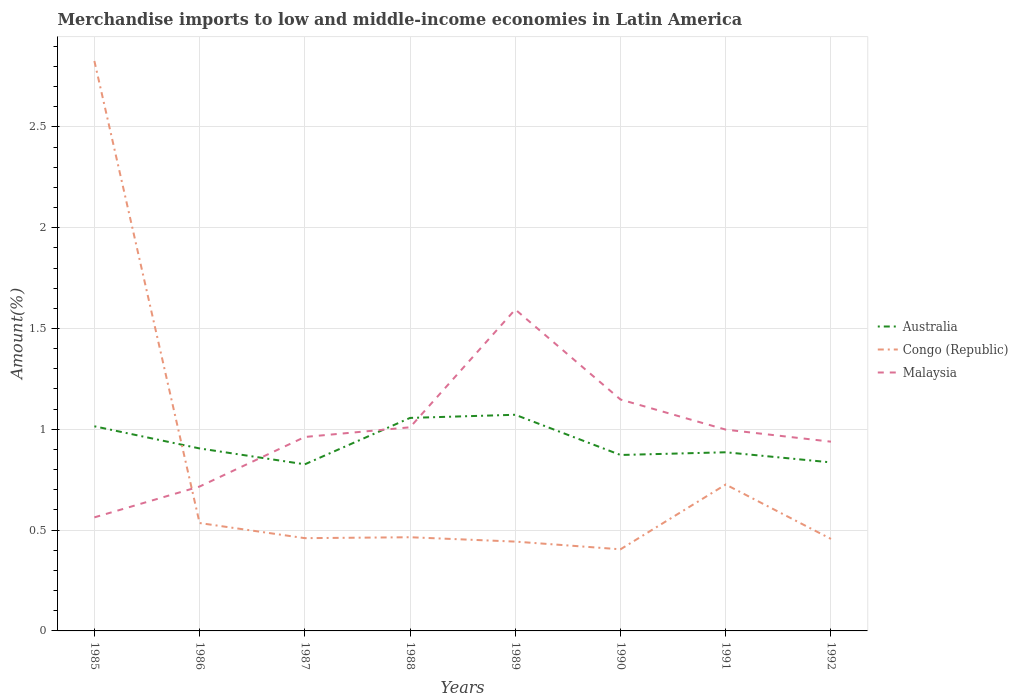Does the line corresponding to Australia intersect with the line corresponding to Congo (Republic)?
Provide a succinct answer. Yes. Across all years, what is the maximum percentage of amount earned from merchandise imports in Malaysia?
Provide a short and direct response. 0.56. In which year was the percentage of amount earned from merchandise imports in Congo (Republic) maximum?
Your answer should be compact. 1990. What is the total percentage of amount earned from merchandise imports in Malaysia in the graph?
Your answer should be very brief. -0.88. What is the difference between the highest and the second highest percentage of amount earned from merchandise imports in Australia?
Provide a succinct answer. 0.25. How many lines are there?
Give a very brief answer. 3. How many years are there in the graph?
Offer a terse response. 8. Are the values on the major ticks of Y-axis written in scientific E-notation?
Your response must be concise. No. What is the title of the graph?
Your answer should be compact. Merchandise imports to low and middle-income economies in Latin America. Does "Turkey" appear as one of the legend labels in the graph?
Make the answer very short. No. What is the label or title of the Y-axis?
Ensure brevity in your answer.  Amount(%). What is the Amount(%) of Australia in 1985?
Ensure brevity in your answer.  1.01. What is the Amount(%) in Congo (Republic) in 1985?
Your response must be concise. 2.83. What is the Amount(%) of Malaysia in 1985?
Provide a short and direct response. 0.56. What is the Amount(%) of Australia in 1986?
Provide a succinct answer. 0.91. What is the Amount(%) of Congo (Republic) in 1986?
Keep it short and to the point. 0.54. What is the Amount(%) of Malaysia in 1986?
Make the answer very short. 0.72. What is the Amount(%) of Australia in 1987?
Your answer should be very brief. 0.83. What is the Amount(%) of Congo (Republic) in 1987?
Ensure brevity in your answer.  0.46. What is the Amount(%) in Malaysia in 1987?
Your answer should be compact. 0.96. What is the Amount(%) of Australia in 1988?
Offer a very short reply. 1.06. What is the Amount(%) of Congo (Republic) in 1988?
Make the answer very short. 0.46. What is the Amount(%) of Malaysia in 1988?
Provide a short and direct response. 1.01. What is the Amount(%) in Australia in 1989?
Your answer should be compact. 1.07. What is the Amount(%) in Congo (Republic) in 1989?
Provide a succinct answer. 0.44. What is the Amount(%) in Malaysia in 1989?
Offer a very short reply. 1.59. What is the Amount(%) in Australia in 1990?
Offer a terse response. 0.87. What is the Amount(%) of Congo (Republic) in 1990?
Make the answer very short. 0.4. What is the Amount(%) of Malaysia in 1990?
Offer a terse response. 1.15. What is the Amount(%) of Australia in 1991?
Your response must be concise. 0.89. What is the Amount(%) of Congo (Republic) in 1991?
Your answer should be compact. 0.73. What is the Amount(%) of Malaysia in 1991?
Provide a succinct answer. 1. What is the Amount(%) of Australia in 1992?
Provide a succinct answer. 0.84. What is the Amount(%) of Congo (Republic) in 1992?
Your answer should be very brief. 0.46. What is the Amount(%) of Malaysia in 1992?
Your answer should be compact. 0.94. Across all years, what is the maximum Amount(%) of Australia?
Offer a very short reply. 1.07. Across all years, what is the maximum Amount(%) of Congo (Republic)?
Your response must be concise. 2.83. Across all years, what is the maximum Amount(%) in Malaysia?
Your response must be concise. 1.59. Across all years, what is the minimum Amount(%) in Australia?
Provide a short and direct response. 0.83. Across all years, what is the minimum Amount(%) of Congo (Republic)?
Ensure brevity in your answer.  0.4. Across all years, what is the minimum Amount(%) of Malaysia?
Offer a very short reply. 0.56. What is the total Amount(%) in Australia in the graph?
Provide a succinct answer. 7.47. What is the total Amount(%) of Congo (Republic) in the graph?
Keep it short and to the point. 6.32. What is the total Amount(%) of Malaysia in the graph?
Offer a terse response. 7.93. What is the difference between the Amount(%) of Australia in 1985 and that in 1986?
Give a very brief answer. 0.11. What is the difference between the Amount(%) of Congo (Republic) in 1985 and that in 1986?
Your answer should be compact. 2.29. What is the difference between the Amount(%) in Malaysia in 1985 and that in 1986?
Make the answer very short. -0.15. What is the difference between the Amount(%) of Australia in 1985 and that in 1987?
Give a very brief answer. 0.19. What is the difference between the Amount(%) of Congo (Republic) in 1985 and that in 1987?
Offer a terse response. 2.37. What is the difference between the Amount(%) in Malaysia in 1985 and that in 1987?
Keep it short and to the point. -0.4. What is the difference between the Amount(%) in Australia in 1985 and that in 1988?
Ensure brevity in your answer.  -0.04. What is the difference between the Amount(%) of Congo (Republic) in 1985 and that in 1988?
Offer a very short reply. 2.36. What is the difference between the Amount(%) in Malaysia in 1985 and that in 1988?
Provide a succinct answer. -0.45. What is the difference between the Amount(%) in Australia in 1985 and that in 1989?
Make the answer very short. -0.06. What is the difference between the Amount(%) in Congo (Republic) in 1985 and that in 1989?
Provide a succinct answer. 2.38. What is the difference between the Amount(%) in Malaysia in 1985 and that in 1989?
Give a very brief answer. -1.03. What is the difference between the Amount(%) in Australia in 1985 and that in 1990?
Keep it short and to the point. 0.14. What is the difference between the Amount(%) in Congo (Republic) in 1985 and that in 1990?
Your answer should be very brief. 2.42. What is the difference between the Amount(%) of Malaysia in 1985 and that in 1990?
Your answer should be very brief. -0.58. What is the difference between the Amount(%) of Australia in 1985 and that in 1991?
Provide a succinct answer. 0.13. What is the difference between the Amount(%) in Congo (Republic) in 1985 and that in 1991?
Keep it short and to the point. 2.1. What is the difference between the Amount(%) of Malaysia in 1985 and that in 1991?
Keep it short and to the point. -0.44. What is the difference between the Amount(%) of Australia in 1985 and that in 1992?
Your response must be concise. 0.18. What is the difference between the Amount(%) of Congo (Republic) in 1985 and that in 1992?
Your response must be concise. 2.37. What is the difference between the Amount(%) of Malaysia in 1985 and that in 1992?
Provide a succinct answer. -0.38. What is the difference between the Amount(%) of Australia in 1986 and that in 1987?
Offer a very short reply. 0.08. What is the difference between the Amount(%) of Congo (Republic) in 1986 and that in 1987?
Ensure brevity in your answer.  0.07. What is the difference between the Amount(%) of Malaysia in 1986 and that in 1987?
Provide a succinct answer. -0.25. What is the difference between the Amount(%) of Australia in 1986 and that in 1988?
Your answer should be very brief. -0.15. What is the difference between the Amount(%) of Congo (Republic) in 1986 and that in 1988?
Your answer should be very brief. 0.07. What is the difference between the Amount(%) in Malaysia in 1986 and that in 1988?
Offer a very short reply. -0.29. What is the difference between the Amount(%) in Australia in 1986 and that in 1989?
Make the answer very short. -0.17. What is the difference between the Amount(%) of Congo (Republic) in 1986 and that in 1989?
Make the answer very short. 0.09. What is the difference between the Amount(%) in Malaysia in 1986 and that in 1989?
Keep it short and to the point. -0.88. What is the difference between the Amount(%) of Australia in 1986 and that in 1990?
Your answer should be very brief. 0.03. What is the difference between the Amount(%) of Congo (Republic) in 1986 and that in 1990?
Your answer should be compact. 0.13. What is the difference between the Amount(%) in Malaysia in 1986 and that in 1990?
Your answer should be compact. -0.43. What is the difference between the Amount(%) of Australia in 1986 and that in 1991?
Offer a very short reply. 0.02. What is the difference between the Amount(%) in Congo (Republic) in 1986 and that in 1991?
Ensure brevity in your answer.  -0.19. What is the difference between the Amount(%) of Malaysia in 1986 and that in 1991?
Provide a short and direct response. -0.28. What is the difference between the Amount(%) in Australia in 1986 and that in 1992?
Your response must be concise. 0.07. What is the difference between the Amount(%) of Congo (Republic) in 1986 and that in 1992?
Give a very brief answer. 0.08. What is the difference between the Amount(%) of Malaysia in 1986 and that in 1992?
Your response must be concise. -0.22. What is the difference between the Amount(%) in Australia in 1987 and that in 1988?
Your answer should be compact. -0.23. What is the difference between the Amount(%) in Congo (Republic) in 1987 and that in 1988?
Give a very brief answer. -0. What is the difference between the Amount(%) in Malaysia in 1987 and that in 1988?
Give a very brief answer. -0.05. What is the difference between the Amount(%) of Australia in 1987 and that in 1989?
Offer a very short reply. -0.25. What is the difference between the Amount(%) in Congo (Republic) in 1987 and that in 1989?
Provide a short and direct response. 0.02. What is the difference between the Amount(%) in Malaysia in 1987 and that in 1989?
Make the answer very short. -0.63. What is the difference between the Amount(%) of Australia in 1987 and that in 1990?
Provide a short and direct response. -0.05. What is the difference between the Amount(%) of Congo (Republic) in 1987 and that in 1990?
Keep it short and to the point. 0.06. What is the difference between the Amount(%) in Malaysia in 1987 and that in 1990?
Ensure brevity in your answer.  -0.19. What is the difference between the Amount(%) of Australia in 1987 and that in 1991?
Keep it short and to the point. -0.06. What is the difference between the Amount(%) of Congo (Republic) in 1987 and that in 1991?
Your response must be concise. -0.27. What is the difference between the Amount(%) in Malaysia in 1987 and that in 1991?
Provide a succinct answer. -0.04. What is the difference between the Amount(%) of Australia in 1987 and that in 1992?
Your answer should be compact. -0.01. What is the difference between the Amount(%) in Congo (Republic) in 1987 and that in 1992?
Give a very brief answer. 0. What is the difference between the Amount(%) in Malaysia in 1987 and that in 1992?
Give a very brief answer. 0.02. What is the difference between the Amount(%) in Australia in 1988 and that in 1989?
Your answer should be very brief. -0.02. What is the difference between the Amount(%) in Congo (Republic) in 1988 and that in 1989?
Offer a terse response. 0.02. What is the difference between the Amount(%) in Malaysia in 1988 and that in 1989?
Ensure brevity in your answer.  -0.58. What is the difference between the Amount(%) in Australia in 1988 and that in 1990?
Your answer should be compact. 0.18. What is the difference between the Amount(%) in Congo (Republic) in 1988 and that in 1990?
Your response must be concise. 0.06. What is the difference between the Amount(%) in Malaysia in 1988 and that in 1990?
Give a very brief answer. -0.14. What is the difference between the Amount(%) in Australia in 1988 and that in 1991?
Provide a succinct answer. 0.17. What is the difference between the Amount(%) of Congo (Republic) in 1988 and that in 1991?
Ensure brevity in your answer.  -0.26. What is the difference between the Amount(%) in Malaysia in 1988 and that in 1991?
Your answer should be very brief. 0.01. What is the difference between the Amount(%) of Australia in 1988 and that in 1992?
Ensure brevity in your answer.  0.22. What is the difference between the Amount(%) of Congo (Republic) in 1988 and that in 1992?
Your answer should be very brief. 0.01. What is the difference between the Amount(%) of Malaysia in 1988 and that in 1992?
Provide a short and direct response. 0.07. What is the difference between the Amount(%) in Australia in 1989 and that in 1990?
Keep it short and to the point. 0.2. What is the difference between the Amount(%) in Congo (Republic) in 1989 and that in 1990?
Provide a succinct answer. 0.04. What is the difference between the Amount(%) in Malaysia in 1989 and that in 1990?
Provide a short and direct response. 0.45. What is the difference between the Amount(%) in Australia in 1989 and that in 1991?
Offer a very short reply. 0.19. What is the difference between the Amount(%) of Congo (Republic) in 1989 and that in 1991?
Provide a short and direct response. -0.28. What is the difference between the Amount(%) in Malaysia in 1989 and that in 1991?
Keep it short and to the point. 0.6. What is the difference between the Amount(%) of Australia in 1989 and that in 1992?
Provide a short and direct response. 0.24. What is the difference between the Amount(%) of Congo (Republic) in 1989 and that in 1992?
Ensure brevity in your answer.  -0.01. What is the difference between the Amount(%) in Malaysia in 1989 and that in 1992?
Your response must be concise. 0.66. What is the difference between the Amount(%) of Australia in 1990 and that in 1991?
Your answer should be compact. -0.01. What is the difference between the Amount(%) of Congo (Republic) in 1990 and that in 1991?
Keep it short and to the point. -0.32. What is the difference between the Amount(%) in Malaysia in 1990 and that in 1991?
Keep it short and to the point. 0.15. What is the difference between the Amount(%) in Australia in 1990 and that in 1992?
Make the answer very short. 0.04. What is the difference between the Amount(%) of Congo (Republic) in 1990 and that in 1992?
Your response must be concise. -0.05. What is the difference between the Amount(%) in Malaysia in 1990 and that in 1992?
Your response must be concise. 0.21. What is the difference between the Amount(%) of Australia in 1991 and that in 1992?
Your answer should be compact. 0.05. What is the difference between the Amount(%) of Congo (Republic) in 1991 and that in 1992?
Keep it short and to the point. 0.27. What is the difference between the Amount(%) of Malaysia in 1991 and that in 1992?
Your answer should be very brief. 0.06. What is the difference between the Amount(%) of Australia in 1985 and the Amount(%) of Congo (Republic) in 1986?
Your response must be concise. 0.48. What is the difference between the Amount(%) of Australia in 1985 and the Amount(%) of Malaysia in 1986?
Your response must be concise. 0.3. What is the difference between the Amount(%) in Congo (Republic) in 1985 and the Amount(%) in Malaysia in 1986?
Make the answer very short. 2.11. What is the difference between the Amount(%) in Australia in 1985 and the Amount(%) in Congo (Republic) in 1987?
Ensure brevity in your answer.  0.55. What is the difference between the Amount(%) in Australia in 1985 and the Amount(%) in Malaysia in 1987?
Your answer should be very brief. 0.05. What is the difference between the Amount(%) in Congo (Republic) in 1985 and the Amount(%) in Malaysia in 1987?
Provide a short and direct response. 1.86. What is the difference between the Amount(%) in Australia in 1985 and the Amount(%) in Congo (Republic) in 1988?
Your answer should be very brief. 0.55. What is the difference between the Amount(%) in Australia in 1985 and the Amount(%) in Malaysia in 1988?
Provide a short and direct response. 0.01. What is the difference between the Amount(%) of Congo (Republic) in 1985 and the Amount(%) of Malaysia in 1988?
Provide a short and direct response. 1.82. What is the difference between the Amount(%) in Australia in 1985 and the Amount(%) in Congo (Republic) in 1989?
Give a very brief answer. 0.57. What is the difference between the Amount(%) in Australia in 1985 and the Amount(%) in Malaysia in 1989?
Your answer should be very brief. -0.58. What is the difference between the Amount(%) in Congo (Republic) in 1985 and the Amount(%) in Malaysia in 1989?
Offer a terse response. 1.23. What is the difference between the Amount(%) of Australia in 1985 and the Amount(%) of Congo (Republic) in 1990?
Provide a short and direct response. 0.61. What is the difference between the Amount(%) of Australia in 1985 and the Amount(%) of Malaysia in 1990?
Give a very brief answer. -0.13. What is the difference between the Amount(%) of Congo (Republic) in 1985 and the Amount(%) of Malaysia in 1990?
Give a very brief answer. 1.68. What is the difference between the Amount(%) in Australia in 1985 and the Amount(%) in Congo (Republic) in 1991?
Offer a terse response. 0.29. What is the difference between the Amount(%) in Australia in 1985 and the Amount(%) in Malaysia in 1991?
Make the answer very short. 0.02. What is the difference between the Amount(%) in Congo (Republic) in 1985 and the Amount(%) in Malaysia in 1991?
Your response must be concise. 1.83. What is the difference between the Amount(%) of Australia in 1985 and the Amount(%) of Congo (Republic) in 1992?
Give a very brief answer. 0.56. What is the difference between the Amount(%) in Australia in 1985 and the Amount(%) in Malaysia in 1992?
Your response must be concise. 0.08. What is the difference between the Amount(%) of Congo (Republic) in 1985 and the Amount(%) of Malaysia in 1992?
Your answer should be very brief. 1.89. What is the difference between the Amount(%) of Australia in 1986 and the Amount(%) of Congo (Republic) in 1987?
Your answer should be compact. 0.45. What is the difference between the Amount(%) in Australia in 1986 and the Amount(%) in Malaysia in 1987?
Give a very brief answer. -0.06. What is the difference between the Amount(%) of Congo (Republic) in 1986 and the Amount(%) of Malaysia in 1987?
Give a very brief answer. -0.43. What is the difference between the Amount(%) in Australia in 1986 and the Amount(%) in Congo (Republic) in 1988?
Your response must be concise. 0.44. What is the difference between the Amount(%) in Australia in 1986 and the Amount(%) in Malaysia in 1988?
Offer a terse response. -0.1. What is the difference between the Amount(%) of Congo (Republic) in 1986 and the Amount(%) of Malaysia in 1988?
Ensure brevity in your answer.  -0.47. What is the difference between the Amount(%) of Australia in 1986 and the Amount(%) of Congo (Republic) in 1989?
Your answer should be very brief. 0.46. What is the difference between the Amount(%) in Australia in 1986 and the Amount(%) in Malaysia in 1989?
Offer a terse response. -0.69. What is the difference between the Amount(%) of Congo (Republic) in 1986 and the Amount(%) of Malaysia in 1989?
Provide a succinct answer. -1.06. What is the difference between the Amount(%) of Australia in 1986 and the Amount(%) of Congo (Republic) in 1990?
Your answer should be compact. 0.5. What is the difference between the Amount(%) of Australia in 1986 and the Amount(%) of Malaysia in 1990?
Offer a terse response. -0.24. What is the difference between the Amount(%) of Congo (Republic) in 1986 and the Amount(%) of Malaysia in 1990?
Ensure brevity in your answer.  -0.61. What is the difference between the Amount(%) in Australia in 1986 and the Amount(%) in Congo (Republic) in 1991?
Ensure brevity in your answer.  0.18. What is the difference between the Amount(%) of Australia in 1986 and the Amount(%) of Malaysia in 1991?
Offer a terse response. -0.09. What is the difference between the Amount(%) of Congo (Republic) in 1986 and the Amount(%) of Malaysia in 1991?
Give a very brief answer. -0.46. What is the difference between the Amount(%) in Australia in 1986 and the Amount(%) in Congo (Republic) in 1992?
Provide a succinct answer. 0.45. What is the difference between the Amount(%) in Australia in 1986 and the Amount(%) in Malaysia in 1992?
Make the answer very short. -0.03. What is the difference between the Amount(%) in Congo (Republic) in 1986 and the Amount(%) in Malaysia in 1992?
Provide a short and direct response. -0.4. What is the difference between the Amount(%) of Australia in 1987 and the Amount(%) of Congo (Republic) in 1988?
Your response must be concise. 0.36. What is the difference between the Amount(%) of Australia in 1987 and the Amount(%) of Malaysia in 1988?
Ensure brevity in your answer.  -0.18. What is the difference between the Amount(%) of Congo (Republic) in 1987 and the Amount(%) of Malaysia in 1988?
Offer a terse response. -0.55. What is the difference between the Amount(%) in Australia in 1987 and the Amount(%) in Congo (Republic) in 1989?
Keep it short and to the point. 0.38. What is the difference between the Amount(%) of Australia in 1987 and the Amount(%) of Malaysia in 1989?
Offer a very short reply. -0.77. What is the difference between the Amount(%) of Congo (Republic) in 1987 and the Amount(%) of Malaysia in 1989?
Make the answer very short. -1.13. What is the difference between the Amount(%) of Australia in 1987 and the Amount(%) of Congo (Republic) in 1990?
Provide a succinct answer. 0.42. What is the difference between the Amount(%) in Australia in 1987 and the Amount(%) in Malaysia in 1990?
Your answer should be compact. -0.32. What is the difference between the Amount(%) in Congo (Republic) in 1987 and the Amount(%) in Malaysia in 1990?
Provide a short and direct response. -0.69. What is the difference between the Amount(%) in Australia in 1987 and the Amount(%) in Congo (Republic) in 1991?
Make the answer very short. 0.1. What is the difference between the Amount(%) in Australia in 1987 and the Amount(%) in Malaysia in 1991?
Provide a succinct answer. -0.17. What is the difference between the Amount(%) of Congo (Republic) in 1987 and the Amount(%) of Malaysia in 1991?
Your answer should be very brief. -0.54. What is the difference between the Amount(%) in Australia in 1987 and the Amount(%) in Congo (Republic) in 1992?
Provide a succinct answer. 0.37. What is the difference between the Amount(%) of Australia in 1987 and the Amount(%) of Malaysia in 1992?
Offer a very short reply. -0.11. What is the difference between the Amount(%) in Congo (Republic) in 1987 and the Amount(%) in Malaysia in 1992?
Provide a succinct answer. -0.48. What is the difference between the Amount(%) in Australia in 1988 and the Amount(%) in Congo (Republic) in 1989?
Your answer should be very brief. 0.61. What is the difference between the Amount(%) in Australia in 1988 and the Amount(%) in Malaysia in 1989?
Provide a short and direct response. -0.54. What is the difference between the Amount(%) of Congo (Republic) in 1988 and the Amount(%) of Malaysia in 1989?
Offer a very short reply. -1.13. What is the difference between the Amount(%) of Australia in 1988 and the Amount(%) of Congo (Republic) in 1990?
Keep it short and to the point. 0.65. What is the difference between the Amount(%) of Australia in 1988 and the Amount(%) of Malaysia in 1990?
Make the answer very short. -0.09. What is the difference between the Amount(%) of Congo (Republic) in 1988 and the Amount(%) of Malaysia in 1990?
Keep it short and to the point. -0.68. What is the difference between the Amount(%) of Australia in 1988 and the Amount(%) of Congo (Republic) in 1991?
Provide a succinct answer. 0.33. What is the difference between the Amount(%) in Australia in 1988 and the Amount(%) in Malaysia in 1991?
Offer a very short reply. 0.06. What is the difference between the Amount(%) in Congo (Republic) in 1988 and the Amount(%) in Malaysia in 1991?
Offer a terse response. -0.53. What is the difference between the Amount(%) in Australia in 1988 and the Amount(%) in Congo (Republic) in 1992?
Keep it short and to the point. 0.6. What is the difference between the Amount(%) in Australia in 1988 and the Amount(%) in Malaysia in 1992?
Offer a terse response. 0.12. What is the difference between the Amount(%) in Congo (Republic) in 1988 and the Amount(%) in Malaysia in 1992?
Ensure brevity in your answer.  -0.47. What is the difference between the Amount(%) of Australia in 1989 and the Amount(%) of Congo (Republic) in 1990?
Offer a very short reply. 0.67. What is the difference between the Amount(%) of Australia in 1989 and the Amount(%) of Malaysia in 1990?
Offer a terse response. -0.08. What is the difference between the Amount(%) in Congo (Republic) in 1989 and the Amount(%) in Malaysia in 1990?
Provide a succinct answer. -0.7. What is the difference between the Amount(%) in Australia in 1989 and the Amount(%) in Congo (Republic) in 1991?
Make the answer very short. 0.35. What is the difference between the Amount(%) of Australia in 1989 and the Amount(%) of Malaysia in 1991?
Provide a short and direct response. 0.07. What is the difference between the Amount(%) of Congo (Republic) in 1989 and the Amount(%) of Malaysia in 1991?
Keep it short and to the point. -0.56. What is the difference between the Amount(%) of Australia in 1989 and the Amount(%) of Congo (Republic) in 1992?
Offer a terse response. 0.62. What is the difference between the Amount(%) of Australia in 1989 and the Amount(%) of Malaysia in 1992?
Give a very brief answer. 0.13. What is the difference between the Amount(%) in Congo (Republic) in 1989 and the Amount(%) in Malaysia in 1992?
Your answer should be very brief. -0.5. What is the difference between the Amount(%) of Australia in 1990 and the Amount(%) of Congo (Republic) in 1991?
Your response must be concise. 0.15. What is the difference between the Amount(%) in Australia in 1990 and the Amount(%) in Malaysia in 1991?
Keep it short and to the point. -0.13. What is the difference between the Amount(%) in Congo (Republic) in 1990 and the Amount(%) in Malaysia in 1991?
Give a very brief answer. -0.59. What is the difference between the Amount(%) in Australia in 1990 and the Amount(%) in Congo (Republic) in 1992?
Keep it short and to the point. 0.42. What is the difference between the Amount(%) in Australia in 1990 and the Amount(%) in Malaysia in 1992?
Ensure brevity in your answer.  -0.07. What is the difference between the Amount(%) of Congo (Republic) in 1990 and the Amount(%) of Malaysia in 1992?
Provide a short and direct response. -0.53. What is the difference between the Amount(%) in Australia in 1991 and the Amount(%) in Congo (Republic) in 1992?
Your answer should be very brief. 0.43. What is the difference between the Amount(%) of Australia in 1991 and the Amount(%) of Malaysia in 1992?
Ensure brevity in your answer.  -0.05. What is the difference between the Amount(%) in Congo (Republic) in 1991 and the Amount(%) in Malaysia in 1992?
Provide a short and direct response. -0.21. What is the average Amount(%) in Australia per year?
Your response must be concise. 0.93. What is the average Amount(%) in Congo (Republic) per year?
Make the answer very short. 0.79. What is the average Amount(%) in Malaysia per year?
Provide a short and direct response. 0.99. In the year 1985, what is the difference between the Amount(%) in Australia and Amount(%) in Congo (Republic)?
Offer a very short reply. -1.81. In the year 1985, what is the difference between the Amount(%) of Australia and Amount(%) of Malaysia?
Offer a very short reply. 0.45. In the year 1985, what is the difference between the Amount(%) in Congo (Republic) and Amount(%) in Malaysia?
Offer a terse response. 2.26. In the year 1986, what is the difference between the Amount(%) of Australia and Amount(%) of Congo (Republic)?
Your response must be concise. 0.37. In the year 1986, what is the difference between the Amount(%) in Australia and Amount(%) in Malaysia?
Provide a short and direct response. 0.19. In the year 1986, what is the difference between the Amount(%) in Congo (Republic) and Amount(%) in Malaysia?
Your response must be concise. -0.18. In the year 1987, what is the difference between the Amount(%) of Australia and Amount(%) of Congo (Republic)?
Offer a very short reply. 0.37. In the year 1987, what is the difference between the Amount(%) of Australia and Amount(%) of Malaysia?
Offer a very short reply. -0.14. In the year 1987, what is the difference between the Amount(%) of Congo (Republic) and Amount(%) of Malaysia?
Provide a short and direct response. -0.5. In the year 1988, what is the difference between the Amount(%) of Australia and Amount(%) of Congo (Republic)?
Give a very brief answer. 0.59. In the year 1988, what is the difference between the Amount(%) in Australia and Amount(%) in Malaysia?
Provide a short and direct response. 0.05. In the year 1988, what is the difference between the Amount(%) in Congo (Republic) and Amount(%) in Malaysia?
Your answer should be very brief. -0.55. In the year 1989, what is the difference between the Amount(%) in Australia and Amount(%) in Congo (Republic)?
Your answer should be very brief. 0.63. In the year 1989, what is the difference between the Amount(%) in Australia and Amount(%) in Malaysia?
Your answer should be very brief. -0.52. In the year 1989, what is the difference between the Amount(%) in Congo (Republic) and Amount(%) in Malaysia?
Your answer should be very brief. -1.15. In the year 1990, what is the difference between the Amount(%) in Australia and Amount(%) in Congo (Republic)?
Your answer should be compact. 0.47. In the year 1990, what is the difference between the Amount(%) in Australia and Amount(%) in Malaysia?
Keep it short and to the point. -0.28. In the year 1990, what is the difference between the Amount(%) of Congo (Republic) and Amount(%) of Malaysia?
Give a very brief answer. -0.74. In the year 1991, what is the difference between the Amount(%) of Australia and Amount(%) of Congo (Republic)?
Keep it short and to the point. 0.16. In the year 1991, what is the difference between the Amount(%) in Australia and Amount(%) in Malaysia?
Your answer should be very brief. -0.11. In the year 1991, what is the difference between the Amount(%) of Congo (Republic) and Amount(%) of Malaysia?
Your answer should be compact. -0.27. In the year 1992, what is the difference between the Amount(%) in Australia and Amount(%) in Congo (Republic)?
Your response must be concise. 0.38. In the year 1992, what is the difference between the Amount(%) in Australia and Amount(%) in Malaysia?
Offer a terse response. -0.1. In the year 1992, what is the difference between the Amount(%) in Congo (Republic) and Amount(%) in Malaysia?
Your answer should be very brief. -0.48. What is the ratio of the Amount(%) of Australia in 1985 to that in 1986?
Your response must be concise. 1.12. What is the ratio of the Amount(%) of Congo (Republic) in 1985 to that in 1986?
Your answer should be very brief. 5.28. What is the ratio of the Amount(%) in Malaysia in 1985 to that in 1986?
Offer a very short reply. 0.79. What is the ratio of the Amount(%) in Australia in 1985 to that in 1987?
Your answer should be very brief. 1.23. What is the ratio of the Amount(%) in Congo (Republic) in 1985 to that in 1987?
Give a very brief answer. 6.14. What is the ratio of the Amount(%) in Malaysia in 1985 to that in 1987?
Give a very brief answer. 0.59. What is the ratio of the Amount(%) of Australia in 1985 to that in 1988?
Provide a short and direct response. 0.96. What is the ratio of the Amount(%) of Congo (Republic) in 1985 to that in 1988?
Provide a succinct answer. 6.08. What is the ratio of the Amount(%) of Malaysia in 1985 to that in 1988?
Offer a very short reply. 0.56. What is the ratio of the Amount(%) of Australia in 1985 to that in 1989?
Ensure brevity in your answer.  0.95. What is the ratio of the Amount(%) of Congo (Republic) in 1985 to that in 1989?
Keep it short and to the point. 6.38. What is the ratio of the Amount(%) of Malaysia in 1985 to that in 1989?
Give a very brief answer. 0.35. What is the ratio of the Amount(%) in Australia in 1985 to that in 1990?
Make the answer very short. 1.16. What is the ratio of the Amount(%) in Congo (Republic) in 1985 to that in 1990?
Make the answer very short. 6.98. What is the ratio of the Amount(%) in Malaysia in 1985 to that in 1990?
Your response must be concise. 0.49. What is the ratio of the Amount(%) of Australia in 1985 to that in 1991?
Your response must be concise. 1.15. What is the ratio of the Amount(%) in Congo (Republic) in 1985 to that in 1991?
Offer a very short reply. 3.89. What is the ratio of the Amount(%) of Malaysia in 1985 to that in 1991?
Ensure brevity in your answer.  0.56. What is the ratio of the Amount(%) in Australia in 1985 to that in 1992?
Your answer should be compact. 1.21. What is the ratio of the Amount(%) in Congo (Republic) in 1985 to that in 1992?
Keep it short and to the point. 6.19. What is the ratio of the Amount(%) in Malaysia in 1985 to that in 1992?
Keep it short and to the point. 0.6. What is the ratio of the Amount(%) of Australia in 1986 to that in 1987?
Ensure brevity in your answer.  1.1. What is the ratio of the Amount(%) in Congo (Republic) in 1986 to that in 1987?
Your answer should be compact. 1.16. What is the ratio of the Amount(%) of Malaysia in 1986 to that in 1987?
Give a very brief answer. 0.74. What is the ratio of the Amount(%) in Australia in 1986 to that in 1988?
Offer a very short reply. 0.86. What is the ratio of the Amount(%) in Congo (Republic) in 1986 to that in 1988?
Keep it short and to the point. 1.15. What is the ratio of the Amount(%) of Malaysia in 1986 to that in 1988?
Make the answer very short. 0.71. What is the ratio of the Amount(%) in Australia in 1986 to that in 1989?
Your answer should be very brief. 0.84. What is the ratio of the Amount(%) of Congo (Republic) in 1986 to that in 1989?
Make the answer very short. 1.21. What is the ratio of the Amount(%) in Malaysia in 1986 to that in 1989?
Offer a very short reply. 0.45. What is the ratio of the Amount(%) of Australia in 1986 to that in 1990?
Give a very brief answer. 1.04. What is the ratio of the Amount(%) in Congo (Republic) in 1986 to that in 1990?
Offer a terse response. 1.32. What is the ratio of the Amount(%) of Malaysia in 1986 to that in 1990?
Offer a terse response. 0.62. What is the ratio of the Amount(%) of Australia in 1986 to that in 1991?
Ensure brevity in your answer.  1.02. What is the ratio of the Amount(%) in Congo (Republic) in 1986 to that in 1991?
Offer a very short reply. 0.74. What is the ratio of the Amount(%) of Malaysia in 1986 to that in 1991?
Offer a very short reply. 0.72. What is the ratio of the Amount(%) in Australia in 1986 to that in 1992?
Keep it short and to the point. 1.08. What is the ratio of the Amount(%) in Congo (Republic) in 1986 to that in 1992?
Your answer should be compact. 1.17. What is the ratio of the Amount(%) of Malaysia in 1986 to that in 1992?
Offer a very short reply. 0.76. What is the ratio of the Amount(%) in Australia in 1987 to that in 1988?
Offer a very short reply. 0.78. What is the ratio of the Amount(%) of Congo (Republic) in 1987 to that in 1988?
Give a very brief answer. 0.99. What is the ratio of the Amount(%) in Malaysia in 1987 to that in 1988?
Provide a succinct answer. 0.95. What is the ratio of the Amount(%) of Australia in 1987 to that in 1989?
Make the answer very short. 0.77. What is the ratio of the Amount(%) of Congo (Republic) in 1987 to that in 1989?
Give a very brief answer. 1.04. What is the ratio of the Amount(%) of Malaysia in 1987 to that in 1989?
Keep it short and to the point. 0.6. What is the ratio of the Amount(%) of Australia in 1987 to that in 1990?
Your response must be concise. 0.95. What is the ratio of the Amount(%) of Congo (Republic) in 1987 to that in 1990?
Keep it short and to the point. 1.14. What is the ratio of the Amount(%) of Malaysia in 1987 to that in 1990?
Offer a very short reply. 0.84. What is the ratio of the Amount(%) of Australia in 1987 to that in 1991?
Offer a terse response. 0.93. What is the ratio of the Amount(%) of Congo (Republic) in 1987 to that in 1991?
Your answer should be compact. 0.63. What is the ratio of the Amount(%) of Malaysia in 1987 to that in 1991?
Make the answer very short. 0.96. What is the ratio of the Amount(%) of Congo (Republic) in 1987 to that in 1992?
Offer a terse response. 1.01. What is the ratio of the Amount(%) in Malaysia in 1987 to that in 1992?
Offer a very short reply. 1.02. What is the ratio of the Amount(%) in Australia in 1988 to that in 1989?
Your answer should be very brief. 0.99. What is the ratio of the Amount(%) of Congo (Republic) in 1988 to that in 1989?
Your answer should be compact. 1.05. What is the ratio of the Amount(%) of Malaysia in 1988 to that in 1989?
Give a very brief answer. 0.63. What is the ratio of the Amount(%) in Australia in 1988 to that in 1990?
Give a very brief answer. 1.21. What is the ratio of the Amount(%) of Congo (Republic) in 1988 to that in 1990?
Provide a succinct answer. 1.15. What is the ratio of the Amount(%) of Australia in 1988 to that in 1991?
Give a very brief answer. 1.19. What is the ratio of the Amount(%) in Congo (Republic) in 1988 to that in 1991?
Your answer should be very brief. 0.64. What is the ratio of the Amount(%) of Malaysia in 1988 to that in 1991?
Provide a short and direct response. 1.01. What is the ratio of the Amount(%) in Australia in 1988 to that in 1992?
Provide a succinct answer. 1.26. What is the ratio of the Amount(%) of Congo (Republic) in 1988 to that in 1992?
Your response must be concise. 1.02. What is the ratio of the Amount(%) in Malaysia in 1988 to that in 1992?
Your response must be concise. 1.08. What is the ratio of the Amount(%) in Australia in 1989 to that in 1990?
Your response must be concise. 1.23. What is the ratio of the Amount(%) in Congo (Republic) in 1989 to that in 1990?
Provide a succinct answer. 1.09. What is the ratio of the Amount(%) of Malaysia in 1989 to that in 1990?
Your response must be concise. 1.39. What is the ratio of the Amount(%) in Australia in 1989 to that in 1991?
Offer a very short reply. 1.21. What is the ratio of the Amount(%) of Congo (Republic) in 1989 to that in 1991?
Your answer should be compact. 0.61. What is the ratio of the Amount(%) of Malaysia in 1989 to that in 1991?
Keep it short and to the point. 1.6. What is the ratio of the Amount(%) in Australia in 1989 to that in 1992?
Ensure brevity in your answer.  1.28. What is the ratio of the Amount(%) of Congo (Republic) in 1989 to that in 1992?
Provide a succinct answer. 0.97. What is the ratio of the Amount(%) in Malaysia in 1989 to that in 1992?
Offer a very short reply. 1.7. What is the ratio of the Amount(%) in Congo (Republic) in 1990 to that in 1991?
Give a very brief answer. 0.56. What is the ratio of the Amount(%) of Malaysia in 1990 to that in 1991?
Your answer should be compact. 1.15. What is the ratio of the Amount(%) in Australia in 1990 to that in 1992?
Provide a short and direct response. 1.04. What is the ratio of the Amount(%) of Congo (Republic) in 1990 to that in 1992?
Keep it short and to the point. 0.89. What is the ratio of the Amount(%) of Malaysia in 1990 to that in 1992?
Make the answer very short. 1.22. What is the ratio of the Amount(%) of Australia in 1991 to that in 1992?
Provide a short and direct response. 1.06. What is the ratio of the Amount(%) in Congo (Republic) in 1991 to that in 1992?
Offer a terse response. 1.59. What is the ratio of the Amount(%) in Malaysia in 1991 to that in 1992?
Your response must be concise. 1.06. What is the difference between the highest and the second highest Amount(%) of Australia?
Make the answer very short. 0.02. What is the difference between the highest and the second highest Amount(%) of Congo (Republic)?
Your answer should be compact. 2.1. What is the difference between the highest and the second highest Amount(%) of Malaysia?
Your response must be concise. 0.45. What is the difference between the highest and the lowest Amount(%) in Australia?
Offer a terse response. 0.25. What is the difference between the highest and the lowest Amount(%) of Congo (Republic)?
Offer a very short reply. 2.42. What is the difference between the highest and the lowest Amount(%) of Malaysia?
Offer a terse response. 1.03. 